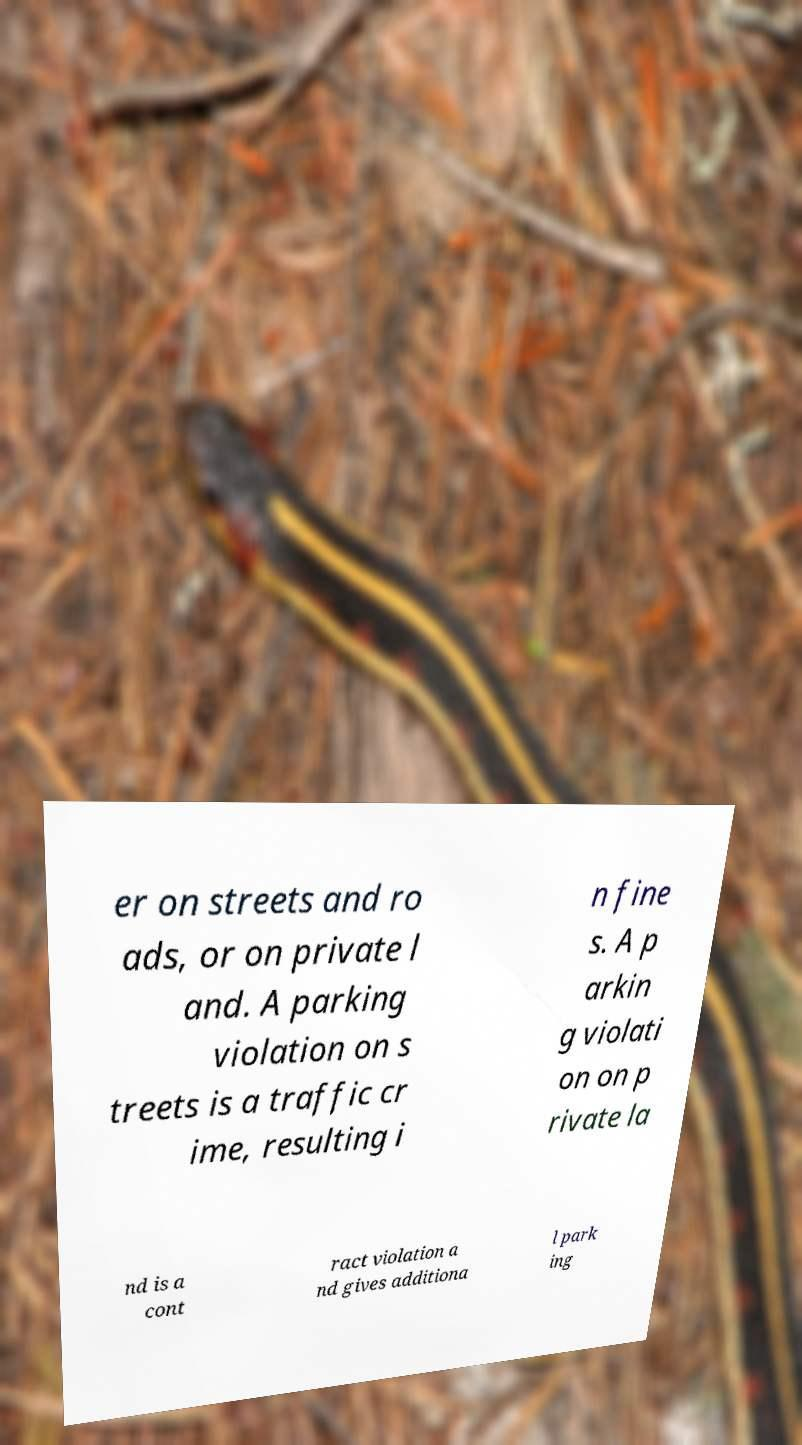Can you read and provide the text displayed in the image?This photo seems to have some interesting text. Can you extract and type it out for me? er on streets and ro ads, or on private l and. A parking violation on s treets is a traffic cr ime, resulting i n fine s. A p arkin g violati on on p rivate la nd is a cont ract violation a nd gives additiona l park ing 